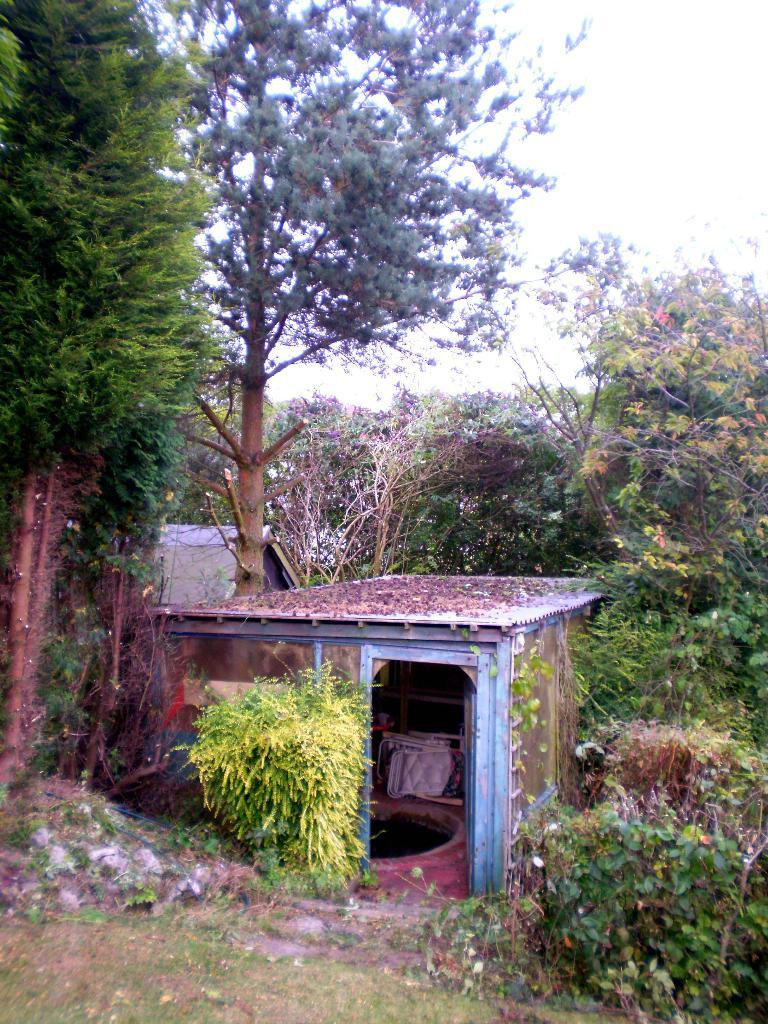What type of structure is in the picture? There is a house in the picture. What can be seen in the background of the picture? There are trees in the background of the picture. What type of vegetation is visible in the picture? There is grass visible in the picture. What else can be seen at the bottom of the picture? There are plants at the bottom of the picture. What is visible at the top of the picture? The sky is visible at the top of the picture. How many jellyfish are swimming in the sky in the image? There are no jellyfish present in the image, and the sky is not a body of water where jellyfish would be found. 